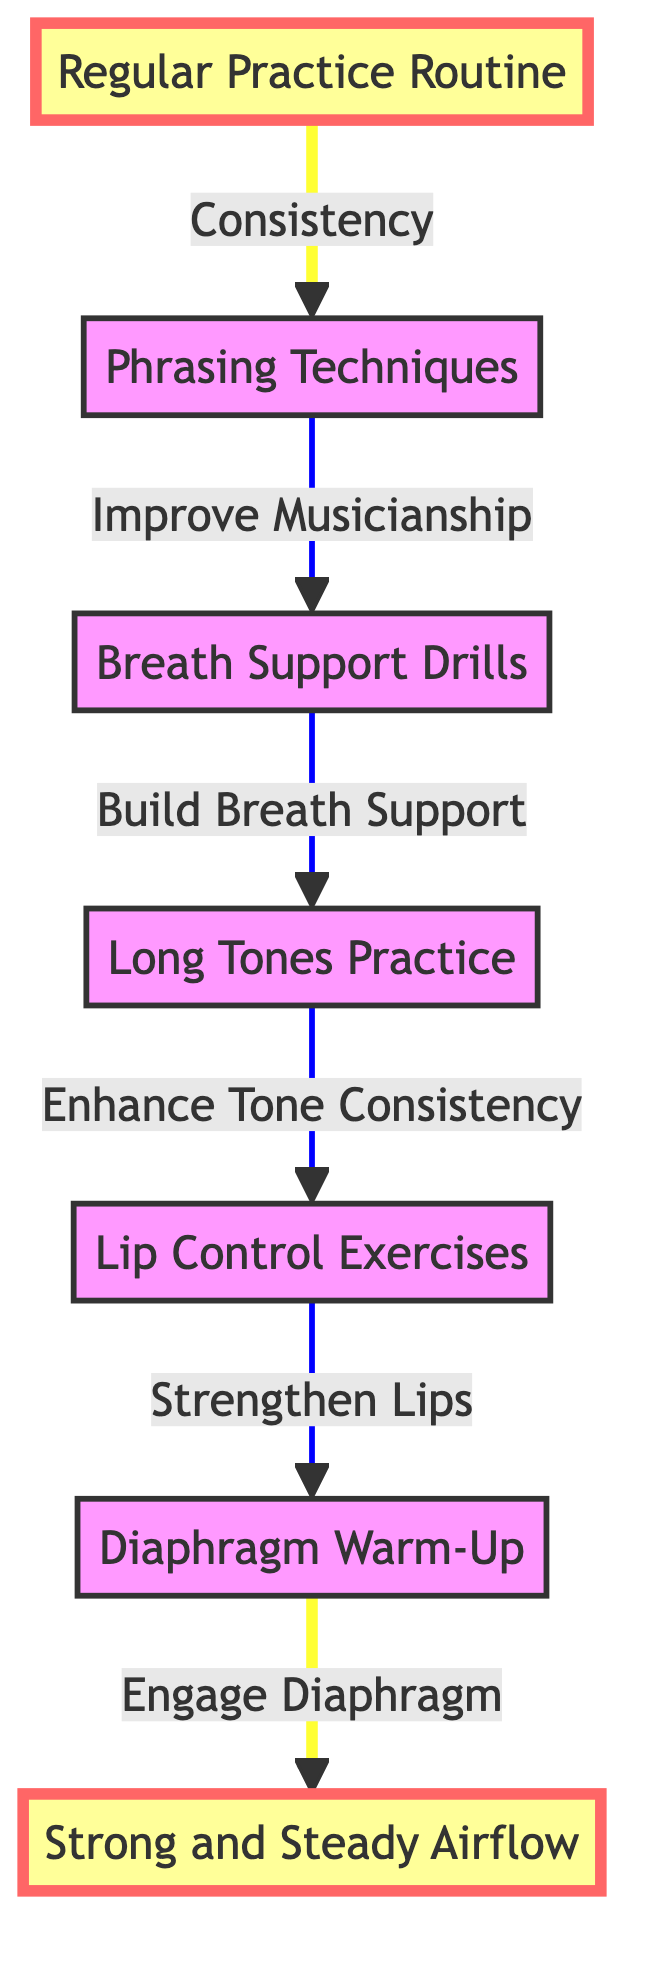What is the first element in the routine? The first element in the routine, as indicated by the flow chart, is "Regular Practice Routine," which is the starting point of the process.
Answer: Regular Practice Routine What task is associated with "Long Tones Practice"? The task associated with "Long Tones Practice" is "Enhance Tone Consistency," which shows the purpose of this element in the workflow.
Answer: Enhance Tone Consistency How many nodes are present in the diagram? The diagram has a total of six nodes, each representing a specific element in the breath control routine.
Answer: Six What is the last element leading to "Strong and Steady Airflow"? The last element leading to "Strong and Steady Airflow" is "Diaphragm Warm-Up," which directly connects to achieving a strong and steady airflow.
Answer: Diaphragm Warm-Up What element is directly before "Phrasing Techniques"? The element directly before "Phrasing Techniques" is "Regular Practice Routine," indicating the flow towards improving musicianship.
Answer: Regular Practice Routine Which task contributes to building breath support? The task that contributes to building breath support is "Build Breath Support," associated with the element "Breath Support Drills."
Answer: Build Breath Support What do the highlighted nodes in the diagram indicate? The highlighted nodes in the diagram, "Regular Practice Routine" and "Strong and Steady Airflow," indicate crucial starting and ending points in the breath control routine.
Answer: Regular Practice Routine and Strong and Steady Airflow What element comes after "Lip Control Exercises"? The element that comes after "Lip Control Exercises" is "Long Tones Practice," showing the sequential nature of the routine.
Answer: Long Tones Practice How does one achieve a strong and steady airflow? To achieve a strong and steady airflow, one must engage in a sequence of practices starting from "Regular Practice Routine" to "Diaphragm Warm-Up," culminating in strong airflow.
Answer: Through a sequence of practices 